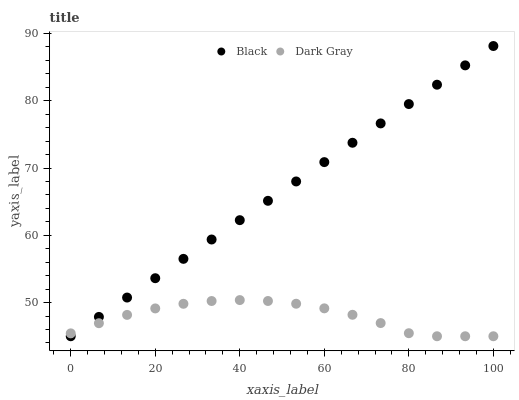Does Dark Gray have the minimum area under the curve?
Answer yes or no. Yes. Does Black have the maximum area under the curve?
Answer yes or no. Yes. Does Black have the minimum area under the curve?
Answer yes or no. No. Is Black the smoothest?
Answer yes or no. Yes. Is Dark Gray the roughest?
Answer yes or no. Yes. Is Black the roughest?
Answer yes or no. No. Does Dark Gray have the lowest value?
Answer yes or no. Yes. Does Black have the highest value?
Answer yes or no. Yes. Does Black intersect Dark Gray?
Answer yes or no. Yes. Is Black less than Dark Gray?
Answer yes or no. No. Is Black greater than Dark Gray?
Answer yes or no. No. 